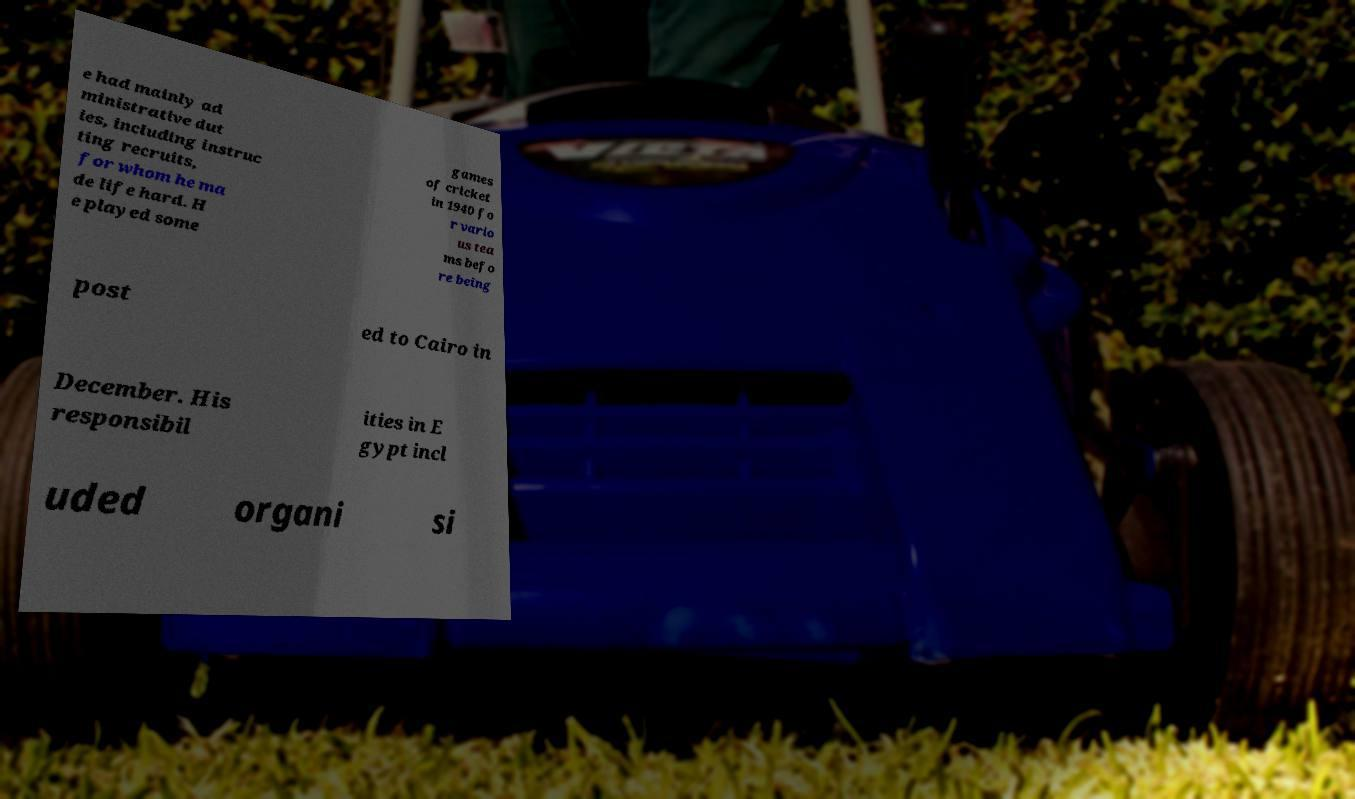What messages or text are displayed in this image? I need them in a readable, typed format. e had mainly ad ministrative dut ies, including instruc ting recruits, for whom he ma de life hard. H e played some games of cricket in 1940 fo r vario us tea ms befo re being post ed to Cairo in December. His responsibil ities in E gypt incl uded organi si 